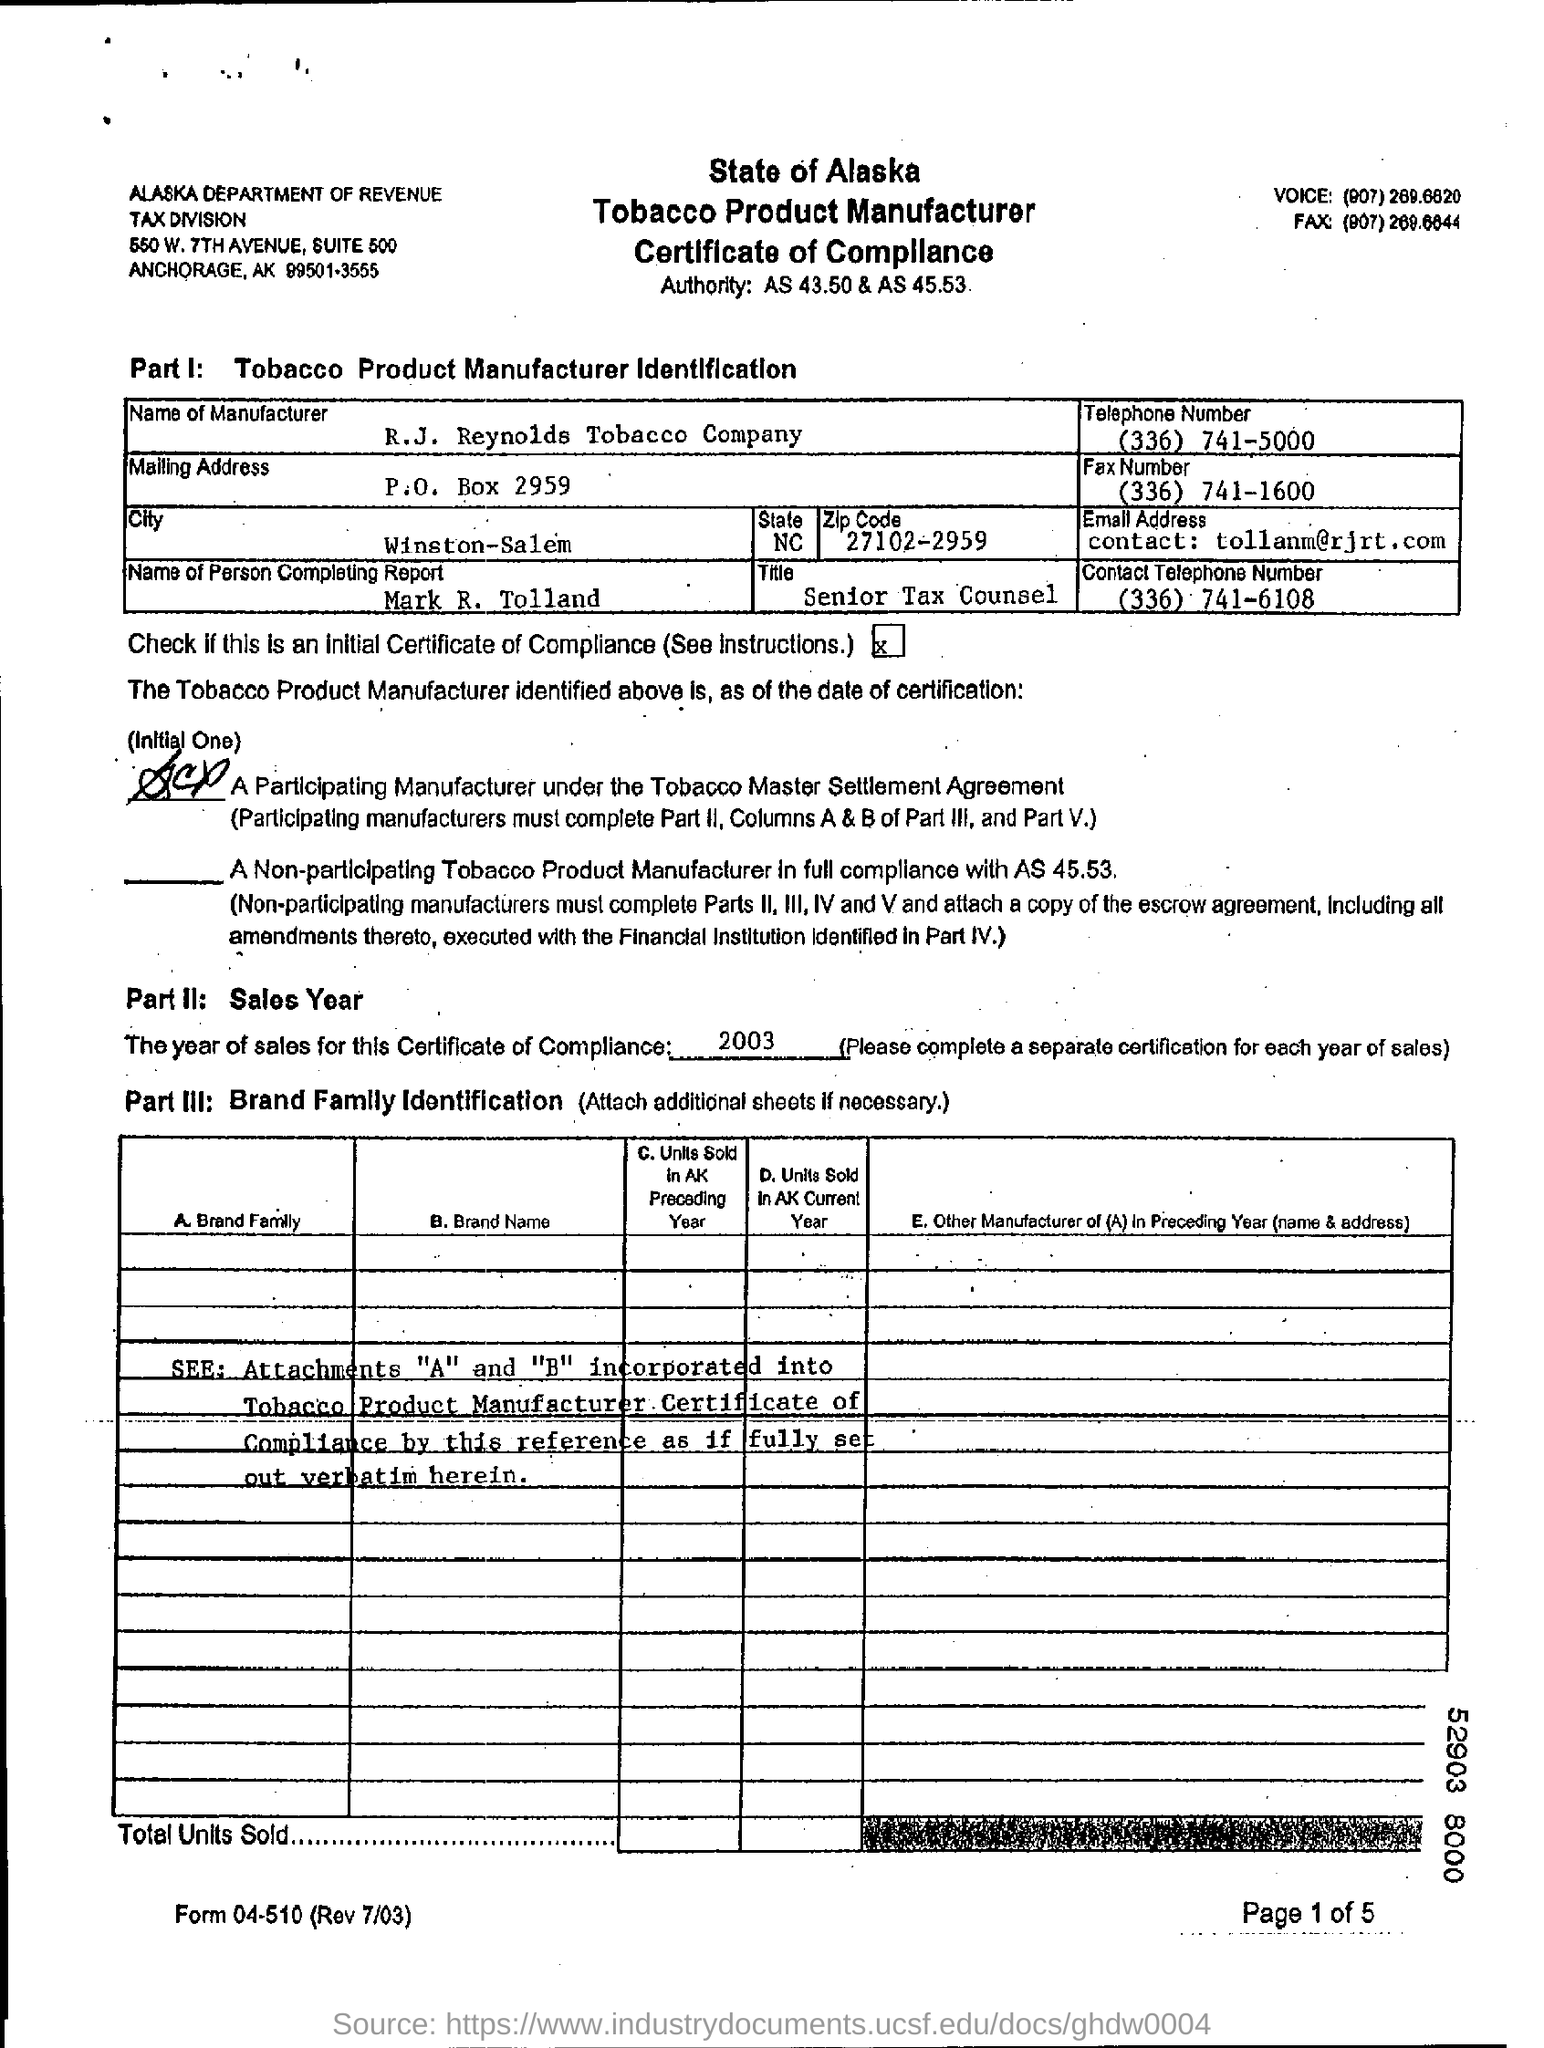Who is the Manufacturer ?
Ensure brevity in your answer.  R.J. Reynolds Tobacco Company. What is P.O. Box Number ?
Your answer should be very brief. 2959. What is the year of sales for this certificate of compliance?
Give a very brief answer. 2003. 